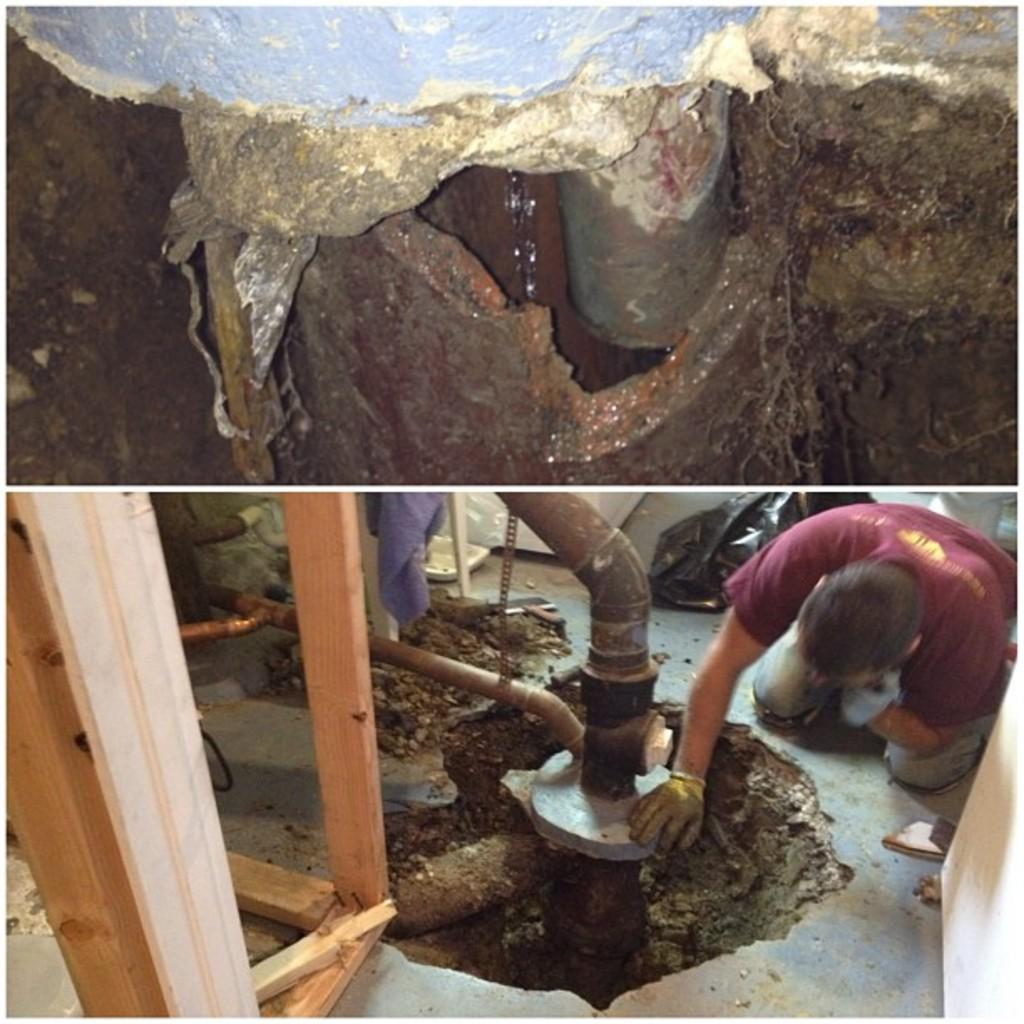What is the main subject of the image? The image contains a collage of pictures. Can you describe one of the pictures in the collage? One picture in the collage shows a pipeline. Are there any people present in the collage? Yes, another picture in the collage shows a person interacting with the pipeline. What type of grass can be seen growing around the pipeline in the image? There is no grass present in the image; it only shows a pipeline and a person interacting with it. 